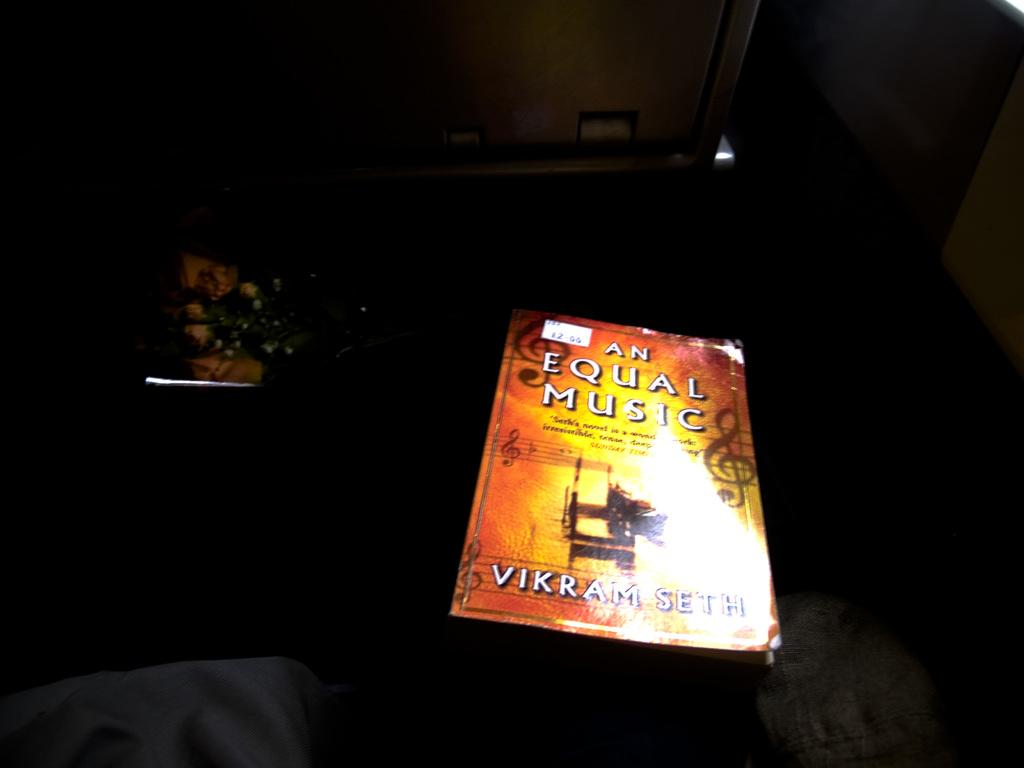<image>
Describe the image concisely. A book titled An Equal Music has a small price tag on its upper left corner. 